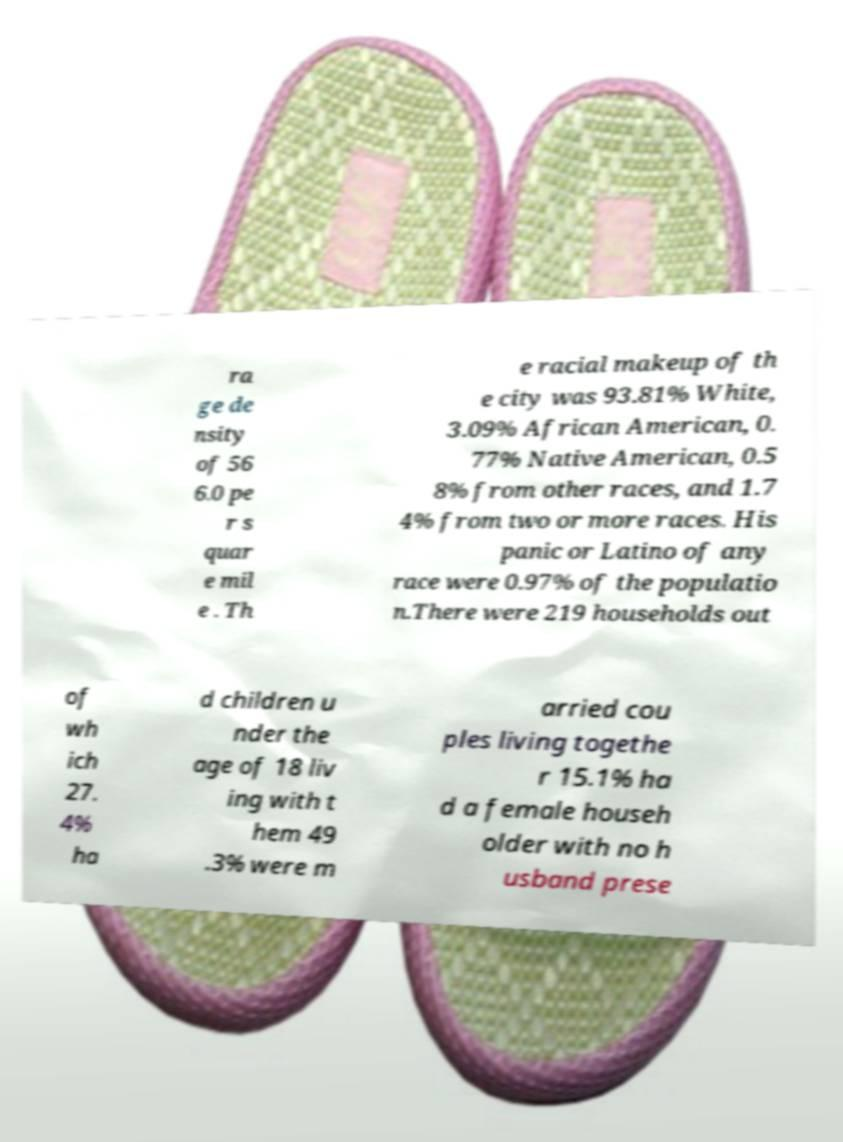There's text embedded in this image that I need extracted. Can you transcribe it verbatim? ra ge de nsity of 56 6.0 pe r s quar e mil e . Th e racial makeup of th e city was 93.81% White, 3.09% African American, 0. 77% Native American, 0.5 8% from other races, and 1.7 4% from two or more races. His panic or Latino of any race were 0.97% of the populatio n.There were 219 households out of wh ich 27. 4% ha d children u nder the age of 18 liv ing with t hem 49 .3% were m arried cou ples living togethe r 15.1% ha d a female househ older with no h usband prese 